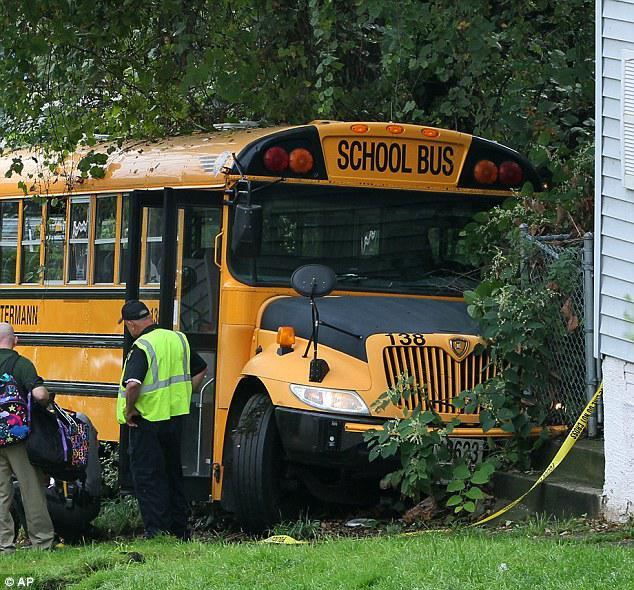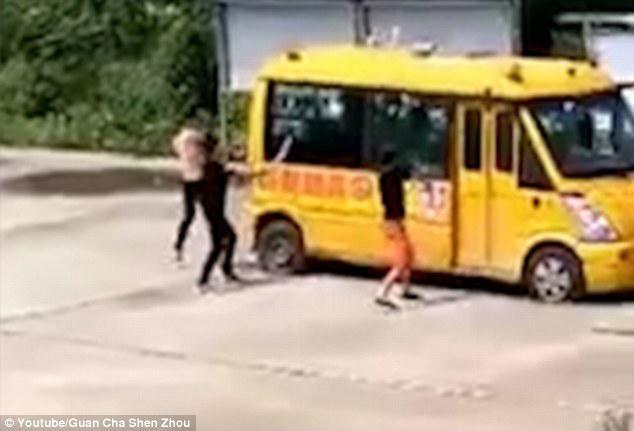The first image is the image on the left, the second image is the image on the right. Analyze the images presented: Is the assertion "At least one of the buses' stop signs is visible." valid? Answer yes or no. No. The first image is the image on the left, the second image is the image on the right. Assess this claim about the two images: "One image shows a flat-front yellow bus, and the other image shows a bus with a hood that projects below the windshield, and all buses are facing somewhat forward.". Correct or not? Answer yes or no. No. 